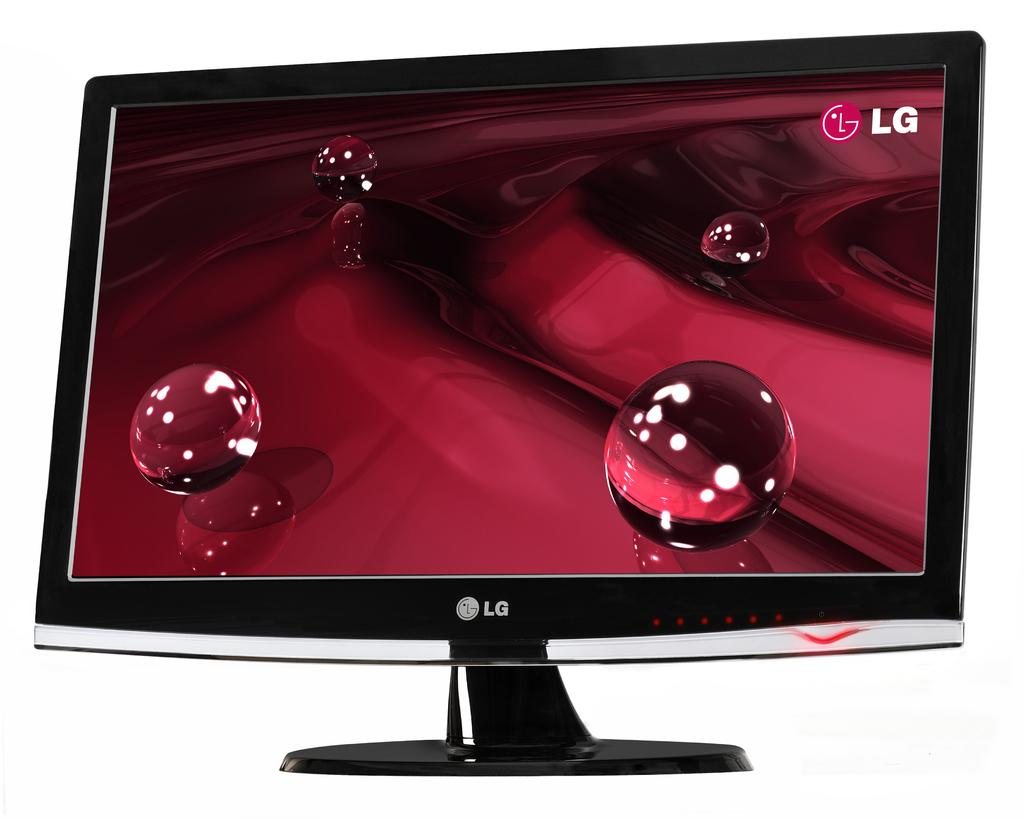<image>
Provide a brief description of the given image. 4 clear marbles are on a rippling red surface, with the LG logo in the top right corner. 